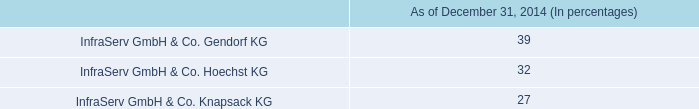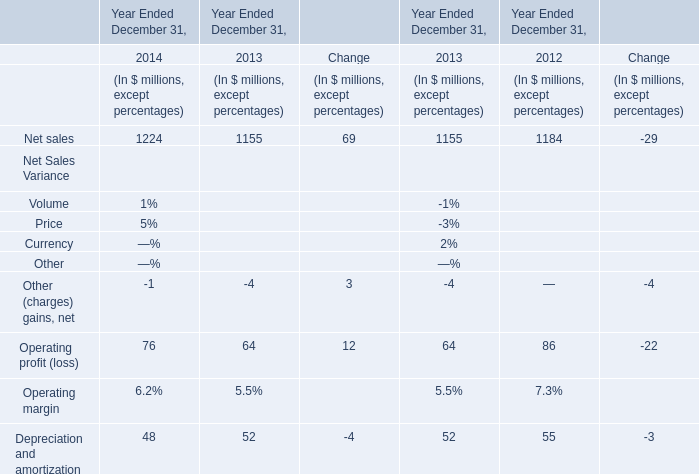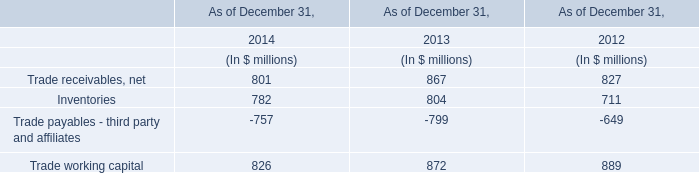what is the growth rate in research and development expenses from 2013 to 2014? 
Computations: ((86 - 85) / 85)
Answer: 0.01176. 